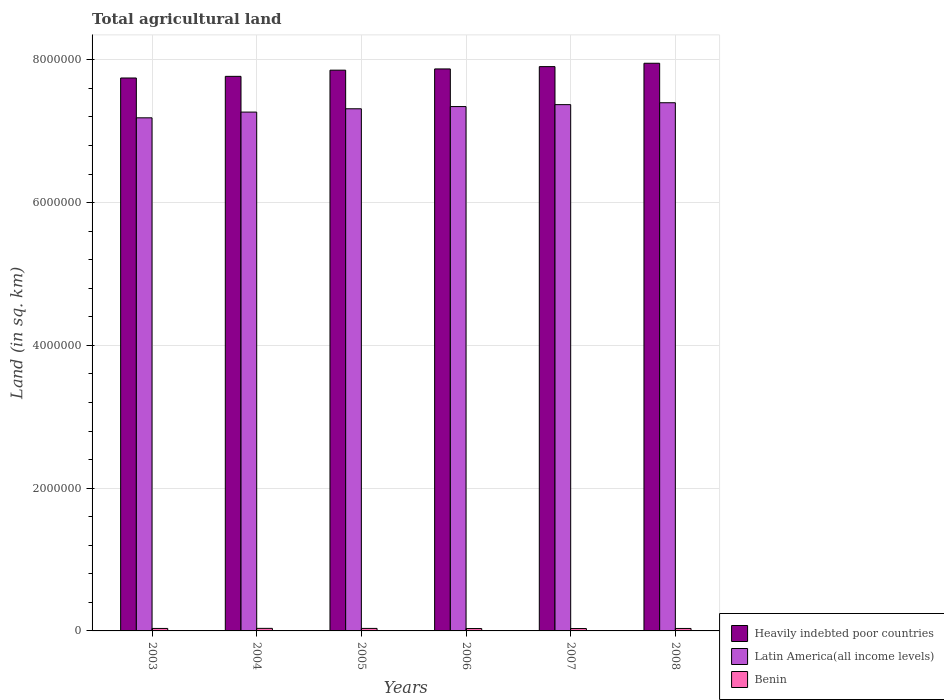How many different coloured bars are there?
Ensure brevity in your answer.  3. How many groups of bars are there?
Keep it short and to the point. 6. Are the number of bars per tick equal to the number of legend labels?
Keep it short and to the point. Yes. How many bars are there on the 4th tick from the right?
Your answer should be very brief. 3. What is the total agricultural land in Benin in 2003?
Your answer should be very brief. 3.47e+04. Across all years, what is the maximum total agricultural land in Benin?
Make the answer very short. 3.57e+04. Across all years, what is the minimum total agricultural land in Heavily indebted poor countries?
Your answer should be compact. 7.74e+06. What is the total total agricultural land in Benin in the graph?
Your answer should be very brief. 2.07e+05. What is the difference between the total agricultural land in Heavily indebted poor countries in 2005 and that in 2007?
Give a very brief answer. -4.97e+04. What is the difference between the total agricultural land in Heavily indebted poor countries in 2008 and the total agricultural land in Latin America(all income levels) in 2007?
Your answer should be very brief. 5.80e+05. What is the average total agricultural land in Heavily indebted poor countries per year?
Offer a terse response. 7.85e+06. In the year 2003, what is the difference between the total agricultural land in Latin America(all income levels) and total agricultural land in Heavily indebted poor countries?
Make the answer very short. -5.58e+05. What is the ratio of the total agricultural land in Heavily indebted poor countries in 2006 to that in 2007?
Ensure brevity in your answer.  1. Is the total agricultural land in Benin in 2003 less than that in 2007?
Provide a short and direct response. No. Is the difference between the total agricultural land in Latin America(all income levels) in 2006 and 2007 greater than the difference between the total agricultural land in Heavily indebted poor countries in 2006 and 2007?
Your answer should be compact. Yes. What is the difference between the highest and the second highest total agricultural land in Latin America(all income levels)?
Your response must be concise. 2.65e+04. What is the difference between the highest and the lowest total agricultural land in Benin?
Provide a succinct answer. 2320. In how many years, is the total agricultural land in Benin greater than the average total agricultural land in Benin taken over all years?
Provide a short and direct response. 3. What does the 1st bar from the left in 2004 represents?
Your answer should be compact. Heavily indebted poor countries. What does the 1st bar from the right in 2008 represents?
Make the answer very short. Benin. How many bars are there?
Your response must be concise. 18. How many years are there in the graph?
Offer a terse response. 6. Are the values on the major ticks of Y-axis written in scientific E-notation?
Provide a short and direct response. No. Does the graph contain any zero values?
Your response must be concise. No. How are the legend labels stacked?
Your answer should be compact. Vertical. What is the title of the graph?
Ensure brevity in your answer.  Total agricultural land. What is the label or title of the Y-axis?
Provide a succinct answer. Land (in sq. km). What is the Land (in sq. km) of Heavily indebted poor countries in 2003?
Keep it short and to the point. 7.74e+06. What is the Land (in sq. km) in Latin America(all income levels) in 2003?
Your answer should be compact. 7.19e+06. What is the Land (in sq. km) in Benin in 2003?
Provide a succinct answer. 3.47e+04. What is the Land (in sq. km) in Heavily indebted poor countries in 2004?
Give a very brief answer. 7.77e+06. What is the Land (in sq. km) in Latin America(all income levels) in 2004?
Your answer should be very brief. 7.27e+06. What is the Land (in sq. km) of Benin in 2004?
Give a very brief answer. 3.57e+04. What is the Land (in sq. km) in Heavily indebted poor countries in 2005?
Your response must be concise. 7.85e+06. What is the Land (in sq. km) in Latin America(all income levels) in 2005?
Provide a short and direct response. 7.31e+06. What is the Land (in sq. km) in Benin in 2005?
Offer a terse response. 3.52e+04. What is the Land (in sq. km) of Heavily indebted poor countries in 2006?
Provide a succinct answer. 7.87e+06. What is the Land (in sq. km) of Latin America(all income levels) in 2006?
Your answer should be very brief. 7.34e+06. What is the Land (in sq. km) of Benin in 2006?
Offer a terse response. 3.34e+04. What is the Land (in sq. km) in Heavily indebted poor countries in 2007?
Your response must be concise. 7.90e+06. What is the Land (in sq. km) of Latin America(all income levels) in 2007?
Offer a very short reply. 7.37e+06. What is the Land (in sq. km) in Benin in 2007?
Provide a succinct answer. 3.34e+04. What is the Land (in sq. km) of Heavily indebted poor countries in 2008?
Make the answer very short. 7.95e+06. What is the Land (in sq. km) of Latin America(all income levels) in 2008?
Your answer should be compact. 7.40e+06. What is the Land (in sq. km) in Benin in 2008?
Give a very brief answer. 3.44e+04. Across all years, what is the maximum Land (in sq. km) in Heavily indebted poor countries?
Provide a succinct answer. 7.95e+06. Across all years, what is the maximum Land (in sq. km) of Latin America(all income levels)?
Provide a succinct answer. 7.40e+06. Across all years, what is the maximum Land (in sq. km) of Benin?
Make the answer very short. 3.57e+04. Across all years, what is the minimum Land (in sq. km) of Heavily indebted poor countries?
Provide a succinct answer. 7.74e+06. Across all years, what is the minimum Land (in sq. km) of Latin America(all income levels)?
Make the answer very short. 7.19e+06. Across all years, what is the minimum Land (in sq. km) in Benin?
Your answer should be compact. 3.34e+04. What is the total Land (in sq. km) of Heavily indebted poor countries in the graph?
Your answer should be compact. 4.71e+07. What is the total Land (in sq. km) of Latin America(all income levels) in the graph?
Provide a succinct answer. 4.39e+07. What is the total Land (in sq. km) in Benin in the graph?
Provide a succinct answer. 2.07e+05. What is the difference between the Land (in sq. km) of Heavily indebted poor countries in 2003 and that in 2004?
Provide a short and direct response. -2.31e+04. What is the difference between the Land (in sq. km) in Latin America(all income levels) in 2003 and that in 2004?
Your answer should be very brief. -8.03e+04. What is the difference between the Land (in sq. km) in Benin in 2003 and that in 2004?
Your response must be concise. -1000. What is the difference between the Land (in sq. km) of Heavily indebted poor countries in 2003 and that in 2005?
Make the answer very short. -1.10e+05. What is the difference between the Land (in sq. km) in Latin America(all income levels) in 2003 and that in 2005?
Provide a short and direct response. -1.27e+05. What is the difference between the Land (in sq. km) of Benin in 2003 and that in 2005?
Make the answer very short. -530. What is the difference between the Land (in sq. km) of Heavily indebted poor countries in 2003 and that in 2006?
Keep it short and to the point. -1.27e+05. What is the difference between the Land (in sq. km) of Latin America(all income levels) in 2003 and that in 2006?
Offer a terse response. -1.58e+05. What is the difference between the Land (in sq. km) of Benin in 2003 and that in 2006?
Offer a terse response. 1320. What is the difference between the Land (in sq. km) in Heavily indebted poor countries in 2003 and that in 2007?
Your response must be concise. -1.59e+05. What is the difference between the Land (in sq. km) of Latin America(all income levels) in 2003 and that in 2007?
Your answer should be very brief. -1.85e+05. What is the difference between the Land (in sq. km) in Benin in 2003 and that in 2007?
Offer a very short reply. 1270. What is the difference between the Land (in sq. km) of Heavily indebted poor countries in 2003 and that in 2008?
Your answer should be compact. -2.06e+05. What is the difference between the Land (in sq. km) of Latin America(all income levels) in 2003 and that in 2008?
Keep it short and to the point. -2.11e+05. What is the difference between the Land (in sq. km) of Benin in 2003 and that in 2008?
Make the answer very short. 220. What is the difference between the Land (in sq. km) of Heavily indebted poor countries in 2004 and that in 2005?
Your response must be concise. -8.66e+04. What is the difference between the Land (in sq. km) in Latin America(all income levels) in 2004 and that in 2005?
Provide a succinct answer. -4.65e+04. What is the difference between the Land (in sq. km) of Benin in 2004 and that in 2005?
Offer a very short reply. 470. What is the difference between the Land (in sq. km) in Heavily indebted poor countries in 2004 and that in 2006?
Keep it short and to the point. -1.04e+05. What is the difference between the Land (in sq. km) in Latin America(all income levels) in 2004 and that in 2006?
Your response must be concise. -7.73e+04. What is the difference between the Land (in sq. km) in Benin in 2004 and that in 2006?
Offer a very short reply. 2320. What is the difference between the Land (in sq. km) in Heavily indebted poor countries in 2004 and that in 2007?
Provide a short and direct response. -1.36e+05. What is the difference between the Land (in sq. km) in Latin America(all income levels) in 2004 and that in 2007?
Provide a short and direct response. -1.04e+05. What is the difference between the Land (in sq. km) in Benin in 2004 and that in 2007?
Your answer should be very brief. 2270. What is the difference between the Land (in sq. km) in Heavily indebted poor countries in 2004 and that in 2008?
Provide a short and direct response. -1.83e+05. What is the difference between the Land (in sq. km) in Latin America(all income levels) in 2004 and that in 2008?
Your answer should be very brief. -1.31e+05. What is the difference between the Land (in sq. km) of Benin in 2004 and that in 2008?
Give a very brief answer. 1220. What is the difference between the Land (in sq. km) in Heavily indebted poor countries in 2005 and that in 2006?
Keep it short and to the point. -1.72e+04. What is the difference between the Land (in sq. km) in Latin America(all income levels) in 2005 and that in 2006?
Your answer should be very brief. -3.07e+04. What is the difference between the Land (in sq. km) in Benin in 2005 and that in 2006?
Your answer should be compact. 1850. What is the difference between the Land (in sq. km) in Heavily indebted poor countries in 2005 and that in 2007?
Give a very brief answer. -4.97e+04. What is the difference between the Land (in sq. km) of Latin America(all income levels) in 2005 and that in 2007?
Offer a very short reply. -5.79e+04. What is the difference between the Land (in sq. km) in Benin in 2005 and that in 2007?
Ensure brevity in your answer.  1800. What is the difference between the Land (in sq. km) of Heavily indebted poor countries in 2005 and that in 2008?
Offer a terse response. -9.68e+04. What is the difference between the Land (in sq. km) in Latin America(all income levels) in 2005 and that in 2008?
Your answer should be compact. -8.44e+04. What is the difference between the Land (in sq. km) of Benin in 2005 and that in 2008?
Ensure brevity in your answer.  750. What is the difference between the Land (in sq. km) of Heavily indebted poor countries in 2006 and that in 2007?
Offer a terse response. -3.24e+04. What is the difference between the Land (in sq. km) of Latin America(all income levels) in 2006 and that in 2007?
Provide a short and direct response. -2.72e+04. What is the difference between the Land (in sq. km) of Heavily indebted poor countries in 2006 and that in 2008?
Your response must be concise. -7.95e+04. What is the difference between the Land (in sq. km) of Latin America(all income levels) in 2006 and that in 2008?
Your answer should be compact. -5.37e+04. What is the difference between the Land (in sq. km) of Benin in 2006 and that in 2008?
Your response must be concise. -1100. What is the difference between the Land (in sq. km) in Heavily indebted poor countries in 2007 and that in 2008?
Provide a succinct answer. -4.71e+04. What is the difference between the Land (in sq. km) in Latin America(all income levels) in 2007 and that in 2008?
Give a very brief answer. -2.65e+04. What is the difference between the Land (in sq. km) in Benin in 2007 and that in 2008?
Your answer should be compact. -1050. What is the difference between the Land (in sq. km) of Heavily indebted poor countries in 2003 and the Land (in sq. km) of Latin America(all income levels) in 2004?
Provide a succinct answer. 4.78e+05. What is the difference between the Land (in sq. km) of Heavily indebted poor countries in 2003 and the Land (in sq. km) of Benin in 2004?
Provide a short and direct response. 7.71e+06. What is the difference between the Land (in sq. km) of Latin America(all income levels) in 2003 and the Land (in sq. km) of Benin in 2004?
Make the answer very short. 7.15e+06. What is the difference between the Land (in sq. km) of Heavily indebted poor countries in 2003 and the Land (in sq. km) of Latin America(all income levels) in 2005?
Your answer should be compact. 4.31e+05. What is the difference between the Land (in sq. km) of Heavily indebted poor countries in 2003 and the Land (in sq. km) of Benin in 2005?
Give a very brief answer. 7.71e+06. What is the difference between the Land (in sq. km) in Latin America(all income levels) in 2003 and the Land (in sq. km) in Benin in 2005?
Give a very brief answer. 7.15e+06. What is the difference between the Land (in sq. km) in Heavily indebted poor countries in 2003 and the Land (in sq. km) in Latin America(all income levels) in 2006?
Your answer should be compact. 4.00e+05. What is the difference between the Land (in sq. km) of Heavily indebted poor countries in 2003 and the Land (in sq. km) of Benin in 2006?
Keep it short and to the point. 7.71e+06. What is the difference between the Land (in sq. km) of Latin America(all income levels) in 2003 and the Land (in sq. km) of Benin in 2006?
Give a very brief answer. 7.15e+06. What is the difference between the Land (in sq. km) in Heavily indebted poor countries in 2003 and the Land (in sq. km) in Latin America(all income levels) in 2007?
Offer a terse response. 3.73e+05. What is the difference between the Land (in sq. km) in Heavily indebted poor countries in 2003 and the Land (in sq. km) in Benin in 2007?
Your response must be concise. 7.71e+06. What is the difference between the Land (in sq. km) of Latin America(all income levels) in 2003 and the Land (in sq. km) of Benin in 2007?
Offer a very short reply. 7.15e+06. What is the difference between the Land (in sq. km) of Heavily indebted poor countries in 2003 and the Land (in sq. km) of Latin America(all income levels) in 2008?
Make the answer very short. 3.47e+05. What is the difference between the Land (in sq. km) in Heavily indebted poor countries in 2003 and the Land (in sq. km) in Benin in 2008?
Provide a succinct answer. 7.71e+06. What is the difference between the Land (in sq. km) in Latin America(all income levels) in 2003 and the Land (in sq. km) in Benin in 2008?
Provide a short and direct response. 7.15e+06. What is the difference between the Land (in sq. km) of Heavily indebted poor countries in 2004 and the Land (in sq. km) of Latin America(all income levels) in 2005?
Offer a very short reply. 4.54e+05. What is the difference between the Land (in sq. km) of Heavily indebted poor countries in 2004 and the Land (in sq. km) of Benin in 2005?
Give a very brief answer. 7.73e+06. What is the difference between the Land (in sq. km) in Latin America(all income levels) in 2004 and the Land (in sq. km) in Benin in 2005?
Offer a very short reply. 7.23e+06. What is the difference between the Land (in sq. km) of Heavily indebted poor countries in 2004 and the Land (in sq. km) of Latin America(all income levels) in 2006?
Give a very brief answer. 4.23e+05. What is the difference between the Land (in sq. km) in Heavily indebted poor countries in 2004 and the Land (in sq. km) in Benin in 2006?
Your response must be concise. 7.73e+06. What is the difference between the Land (in sq. km) of Latin America(all income levels) in 2004 and the Land (in sq. km) of Benin in 2006?
Your answer should be compact. 7.23e+06. What is the difference between the Land (in sq. km) of Heavily indebted poor countries in 2004 and the Land (in sq. km) of Latin America(all income levels) in 2007?
Make the answer very short. 3.96e+05. What is the difference between the Land (in sq. km) in Heavily indebted poor countries in 2004 and the Land (in sq. km) in Benin in 2007?
Offer a very short reply. 7.73e+06. What is the difference between the Land (in sq. km) of Latin America(all income levels) in 2004 and the Land (in sq. km) of Benin in 2007?
Your answer should be compact. 7.23e+06. What is the difference between the Land (in sq. km) of Heavily indebted poor countries in 2004 and the Land (in sq. km) of Latin America(all income levels) in 2008?
Your answer should be very brief. 3.70e+05. What is the difference between the Land (in sq. km) of Heavily indebted poor countries in 2004 and the Land (in sq. km) of Benin in 2008?
Keep it short and to the point. 7.73e+06. What is the difference between the Land (in sq. km) of Latin America(all income levels) in 2004 and the Land (in sq. km) of Benin in 2008?
Your answer should be compact. 7.23e+06. What is the difference between the Land (in sq. km) in Heavily indebted poor countries in 2005 and the Land (in sq. km) in Latin America(all income levels) in 2006?
Provide a short and direct response. 5.10e+05. What is the difference between the Land (in sq. km) of Heavily indebted poor countries in 2005 and the Land (in sq. km) of Benin in 2006?
Your answer should be very brief. 7.82e+06. What is the difference between the Land (in sq. km) of Latin America(all income levels) in 2005 and the Land (in sq. km) of Benin in 2006?
Your response must be concise. 7.28e+06. What is the difference between the Land (in sq. km) in Heavily indebted poor countries in 2005 and the Land (in sq. km) in Latin America(all income levels) in 2007?
Keep it short and to the point. 4.83e+05. What is the difference between the Land (in sq. km) of Heavily indebted poor countries in 2005 and the Land (in sq. km) of Benin in 2007?
Your response must be concise. 7.82e+06. What is the difference between the Land (in sq. km) of Latin America(all income levels) in 2005 and the Land (in sq. km) of Benin in 2007?
Your answer should be compact. 7.28e+06. What is the difference between the Land (in sq. km) in Heavily indebted poor countries in 2005 and the Land (in sq. km) in Latin America(all income levels) in 2008?
Make the answer very short. 4.56e+05. What is the difference between the Land (in sq. km) in Heavily indebted poor countries in 2005 and the Land (in sq. km) in Benin in 2008?
Your answer should be very brief. 7.82e+06. What is the difference between the Land (in sq. km) of Latin America(all income levels) in 2005 and the Land (in sq. km) of Benin in 2008?
Provide a short and direct response. 7.28e+06. What is the difference between the Land (in sq. km) of Heavily indebted poor countries in 2006 and the Land (in sq. km) of Latin America(all income levels) in 2007?
Your answer should be compact. 5.00e+05. What is the difference between the Land (in sq. km) in Heavily indebted poor countries in 2006 and the Land (in sq. km) in Benin in 2007?
Provide a succinct answer. 7.84e+06. What is the difference between the Land (in sq. km) in Latin America(all income levels) in 2006 and the Land (in sq. km) in Benin in 2007?
Offer a very short reply. 7.31e+06. What is the difference between the Land (in sq. km) of Heavily indebted poor countries in 2006 and the Land (in sq. km) of Latin America(all income levels) in 2008?
Provide a succinct answer. 4.73e+05. What is the difference between the Land (in sq. km) in Heavily indebted poor countries in 2006 and the Land (in sq. km) in Benin in 2008?
Your answer should be compact. 7.84e+06. What is the difference between the Land (in sq. km) in Latin America(all income levels) in 2006 and the Land (in sq. km) in Benin in 2008?
Your response must be concise. 7.31e+06. What is the difference between the Land (in sq. km) in Heavily indebted poor countries in 2007 and the Land (in sq. km) in Latin America(all income levels) in 2008?
Give a very brief answer. 5.06e+05. What is the difference between the Land (in sq. km) of Heavily indebted poor countries in 2007 and the Land (in sq. km) of Benin in 2008?
Provide a short and direct response. 7.87e+06. What is the difference between the Land (in sq. km) of Latin America(all income levels) in 2007 and the Land (in sq. km) of Benin in 2008?
Give a very brief answer. 7.34e+06. What is the average Land (in sq. km) in Heavily indebted poor countries per year?
Make the answer very short. 7.85e+06. What is the average Land (in sq. km) of Latin America(all income levels) per year?
Make the answer very short. 7.31e+06. What is the average Land (in sq. km) in Benin per year?
Ensure brevity in your answer.  3.45e+04. In the year 2003, what is the difference between the Land (in sq. km) in Heavily indebted poor countries and Land (in sq. km) in Latin America(all income levels)?
Your response must be concise. 5.58e+05. In the year 2003, what is the difference between the Land (in sq. km) in Heavily indebted poor countries and Land (in sq. km) in Benin?
Your answer should be very brief. 7.71e+06. In the year 2003, what is the difference between the Land (in sq. km) of Latin America(all income levels) and Land (in sq. km) of Benin?
Offer a terse response. 7.15e+06. In the year 2004, what is the difference between the Land (in sq. km) in Heavily indebted poor countries and Land (in sq. km) in Latin America(all income levels)?
Make the answer very short. 5.01e+05. In the year 2004, what is the difference between the Land (in sq. km) of Heavily indebted poor countries and Land (in sq. km) of Benin?
Give a very brief answer. 7.73e+06. In the year 2004, what is the difference between the Land (in sq. km) in Latin America(all income levels) and Land (in sq. km) in Benin?
Your answer should be compact. 7.23e+06. In the year 2005, what is the difference between the Land (in sq. km) of Heavily indebted poor countries and Land (in sq. km) of Latin America(all income levels)?
Provide a short and direct response. 5.41e+05. In the year 2005, what is the difference between the Land (in sq. km) in Heavily indebted poor countries and Land (in sq. km) in Benin?
Ensure brevity in your answer.  7.82e+06. In the year 2005, what is the difference between the Land (in sq. km) in Latin America(all income levels) and Land (in sq. km) in Benin?
Your answer should be compact. 7.28e+06. In the year 2006, what is the difference between the Land (in sq. km) of Heavily indebted poor countries and Land (in sq. km) of Latin America(all income levels)?
Offer a terse response. 5.27e+05. In the year 2006, what is the difference between the Land (in sq. km) in Heavily indebted poor countries and Land (in sq. km) in Benin?
Your answer should be very brief. 7.84e+06. In the year 2006, what is the difference between the Land (in sq. km) in Latin America(all income levels) and Land (in sq. km) in Benin?
Offer a very short reply. 7.31e+06. In the year 2007, what is the difference between the Land (in sq. km) in Heavily indebted poor countries and Land (in sq. km) in Latin America(all income levels)?
Keep it short and to the point. 5.32e+05. In the year 2007, what is the difference between the Land (in sq. km) in Heavily indebted poor countries and Land (in sq. km) in Benin?
Ensure brevity in your answer.  7.87e+06. In the year 2007, what is the difference between the Land (in sq. km) of Latin America(all income levels) and Land (in sq. km) of Benin?
Provide a succinct answer. 7.34e+06. In the year 2008, what is the difference between the Land (in sq. km) of Heavily indebted poor countries and Land (in sq. km) of Latin America(all income levels)?
Make the answer very short. 5.53e+05. In the year 2008, what is the difference between the Land (in sq. km) of Heavily indebted poor countries and Land (in sq. km) of Benin?
Provide a short and direct response. 7.92e+06. In the year 2008, what is the difference between the Land (in sq. km) in Latin America(all income levels) and Land (in sq. km) in Benin?
Your response must be concise. 7.36e+06. What is the ratio of the Land (in sq. km) of Heavily indebted poor countries in 2003 to that in 2004?
Offer a terse response. 1. What is the ratio of the Land (in sq. km) in Latin America(all income levels) in 2003 to that in 2004?
Provide a succinct answer. 0.99. What is the ratio of the Land (in sq. km) of Latin America(all income levels) in 2003 to that in 2005?
Your answer should be compact. 0.98. What is the ratio of the Land (in sq. km) in Benin in 2003 to that in 2005?
Provide a short and direct response. 0.98. What is the ratio of the Land (in sq. km) in Heavily indebted poor countries in 2003 to that in 2006?
Ensure brevity in your answer.  0.98. What is the ratio of the Land (in sq. km) of Latin America(all income levels) in 2003 to that in 2006?
Provide a short and direct response. 0.98. What is the ratio of the Land (in sq. km) in Benin in 2003 to that in 2006?
Offer a very short reply. 1.04. What is the ratio of the Land (in sq. km) in Heavily indebted poor countries in 2003 to that in 2007?
Your answer should be very brief. 0.98. What is the ratio of the Land (in sq. km) of Latin America(all income levels) in 2003 to that in 2007?
Make the answer very short. 0.97. What is the ratio of the Land (in sq. km) of Benin in 2003 to that in 2007?
Keep it short and to the point. 1.04. What is the ratio of the Land (in sq. km) of Heavily indebted poor countries in 2003 to that in 2008?
Your answer should be compact. 0.97. What is the ratio of the Land (in sq. km) of Latin America(all income levels) in 2003 to that in 2008?
Your response must be concise. 0.97. What is the ratio of the Land (in sq. km) of Benin in 2003 to that in 2008?
Your response must be concise. 1.01. What is the ratio of the Land (in sq. km) of Latin America(all income levels) in 2004 to that in 2005?
Ensure brevity in your answer.  0.99. What is the ratio of the Land (in sq. km) of Benin in 2004 to that in 2005?
Provide a succinct answer. 1.01. What is the ratio of the Land (in sq. km) in Heavily indebted poor countries in 2004 to that in 2006?
Your answer should be compact. 0.99. What is the ratio of the Land (in sq. km) of Benin in 2004 to that in 2006?
Keep it short and to the point. 1.07. What is the ratio of the Land (in sq. km) in Heavily indebted poor countries in 2004 to that in 2007?
Offer a very short reply. 0.98. What is the ratio of the Land (in sq. km) in Latin America(all income levels) in 2004 to that in 2007?
Provide a succinct answer. 0.99. What is the ratio of the Land (in sq. km) of Benin in 2004 to that in 2007?
Provide a short and direct response. 1.07. What is the ratio of the Land (in sq. km) of Heavily indebted poor countries in 2004 to that in 2008?
Ensure brevity in your answer.  0.98. What is the ratio of the Land (in sq. km) of Latin America(all income levels) in 2004 to that in 2008?
Offer a very short reply. 0.98. What is the ratio of the Land (in sq. km) in Benin in 2004 to that in 2008?
Offer a very short reply. 1.04. What is the ratio of the Land (in sq. km) of Heavily indebted poor countries in 2005 to that in 2006?
Your response must be concise. 1. What is the ratio of the Land (in sq. km) of Latin America(all income levels) in 2005 to that in 2006?
Keep it short and to the point. 1. What is the ratio of the Land (in sq. km) in Benin in 2005 to that in 2006?
Your answer should be very brief. 1.06. What is the ratio of the Land (in sq. km) in Heavily indebted poor countries in 2005 to that in 2007?
Your answer should be very brief. 0.99. What is the ratio of the Land (in sq. km) in Benin in 2005 to that in 2007?
Provide a succinct answer. 1.05. What is the ratio of the Land (in sq. km) of Heavily indebted poor countries in 2005 to that in 2008?
Ensure brevity in your answer.  0.99. What is the ratio of the Land (in sq. km) in Benin in 2005 to that in 2008?
Make the answer very short. 1.02. What is the ratio of the Land (in sq. km) of Heavily indebted poor countries in 2006 to that in 2007?
Offer a terse response. 1. What is the ratio of the Land (in sq. km) of Heavily indebted poor countries in 2006 to that in 2008?
Your response must be concise. 0.99. What is the ratio of the Land (in sq. km) in Latin America(all income levels) in 2006 to that in 2008?
Your answer should be compact. 0.99. What is the ratio of the Land (in sq. km) in Benin in 2006 to that in 2008?
Ensure brevity in your answer.  0.97. What is the ratio of the Land (in sq. km) of Benin in 2007 to that in 2008?
Give a very brief answer. 0.97. What is the difference between the highest and the second highest Land (in sq. km) in Heavily indebted poor countries?
Provide a succinct answer. 4.71e+04. What is the difference between the highest and the second highest Land (in sq. km) of Latin America(all income levels)?
Provide a succinct answer. 2.65e+04. What is the difference between the highest and the second highest Land (in sq. km) of Benin?
Offer a terse response. 470. What is the difference between the highest and the lowest Land (in sq. km) of Heavily indebted poor countries?
Give a very brief answer. 2.06e+05. What is the difference between the highest and the lowest Land (in sq. km) in Latin America(all income levels)?
Your answer should be compact. 2.11e+05. What is the difference between the highest and the lowest Land (in sq. km) in Benin?
Make the answer very short. 2320. 